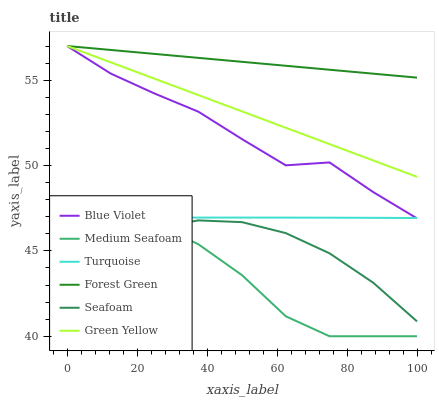Does Medium Seafoam have the minimum area under the curve?
Answer yes or no. Yes. Does Forest Green have the maximum area under the curve?
Answer yes or no. Yes. Does Seafoam have the minimum area under the curve?
Answer yes or no. No. Does Seafoam have the maximum area under the curve?
Answer yes or no. No. Is Green Yellow the smoothest?
Answer yes or no. Yes. Is Blue Violet the roughest?
Answer yes or no. Yes. Is Seafoam the smoothest?
Answer yes or no. No. Is Seafoam the roughest?
Answer yes or no. No. Does Medium Seafoam have the lowest value?
Answer yes or no. Yes. Does Seafoam have the lowest value?
Answer yes or no. No. Does Blue Violet have the highest value?
Answer yes or no. Yes. Does Seafoam have the highest value?
Answer yes or no. No. Is Seafoam less than Turquoise?
Answer yes or no. Yes. Is Forest Green greater than Turquoise?
Answer yes or no. Yes. Does Medium Seafoam intersect Seafoam?
Answer yes or no. Yes. Is Medium Seafoam less than Seafoam?
Answer yes or no. No. Is Medium Seafoam greater than Seafoam?
Answer yes or no. No. Does Seafoam intersect Turquoise?
Answer yes or no. No. 